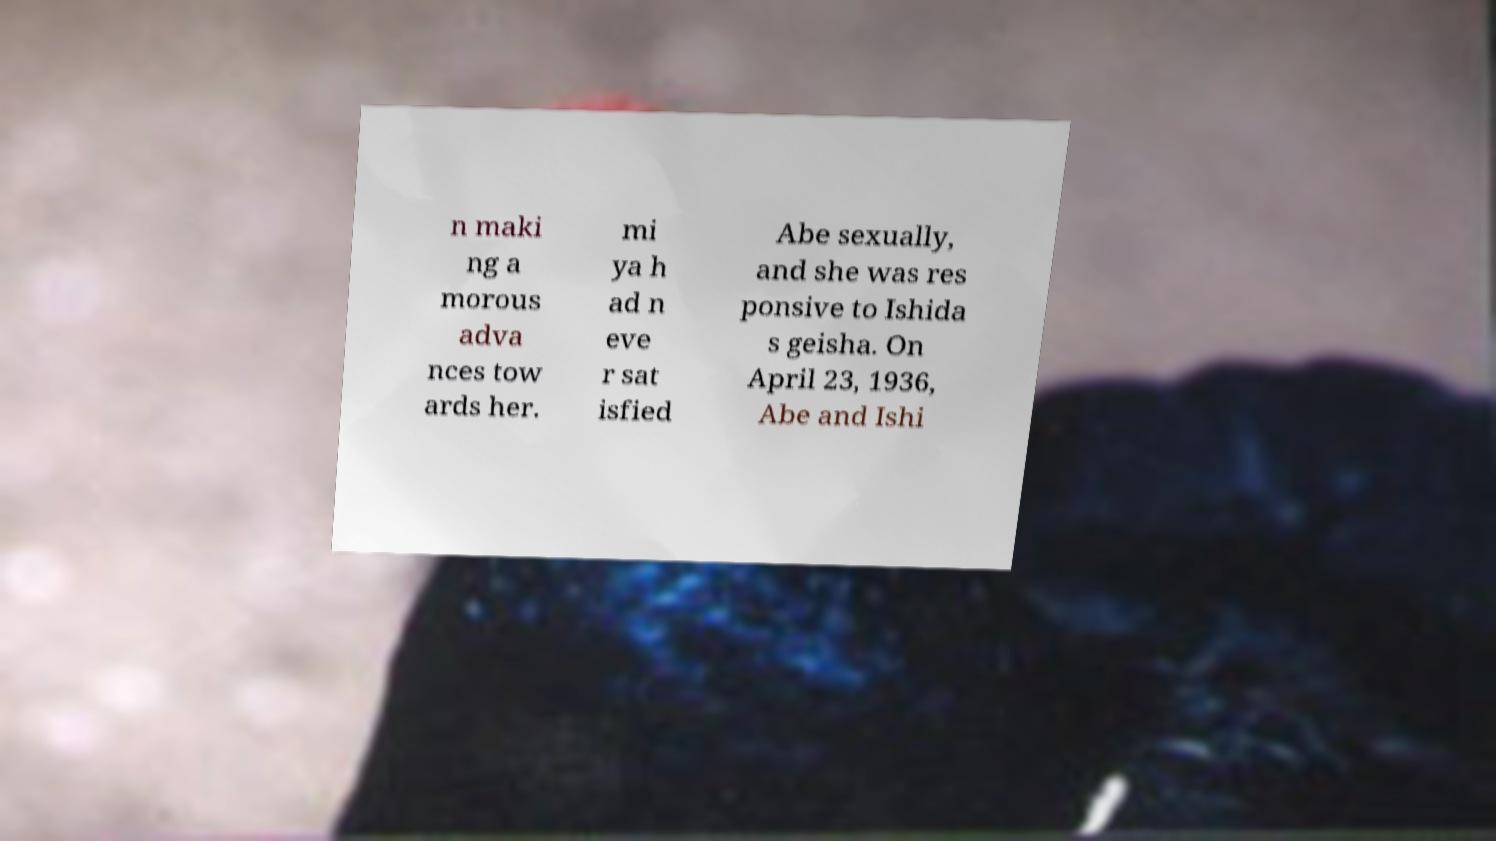Can you accurately transcribe the text from the provided image for me? n maki ng a morous adva nces tow ards her. mi ya h ad n eve r sat isfied Abe sexually, and she was res ponsive to Ishida s geisha. On April 23, 1936, Abe and Ishi 